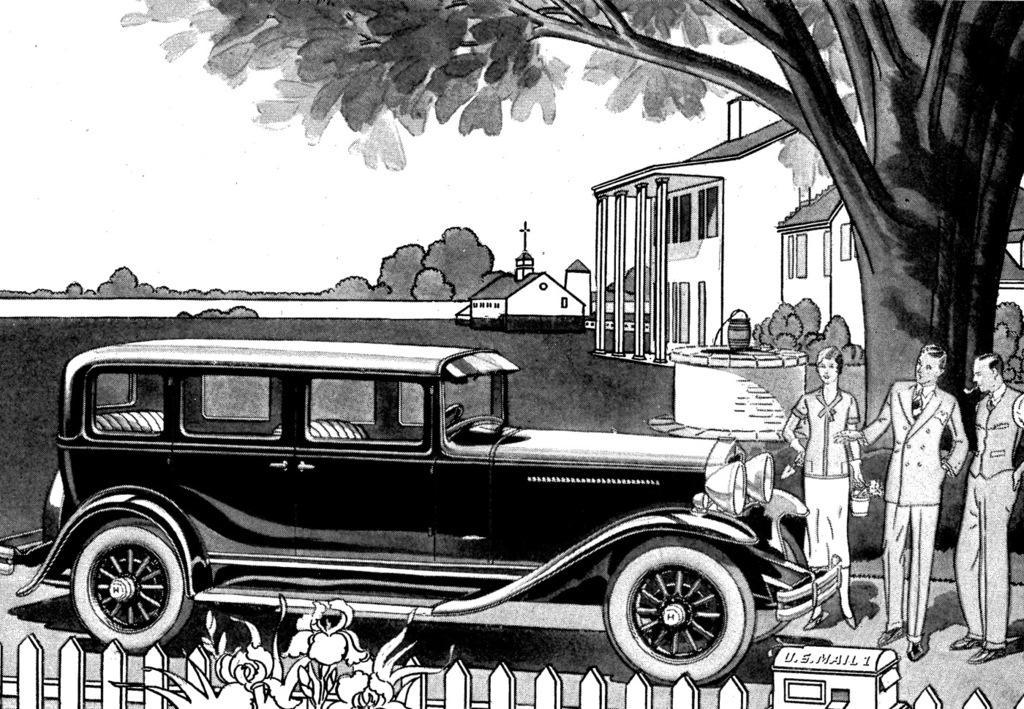Describe this image in one or two sentences. As we can see in the image there is a paper. On paper there is a drawing of fence, plants, trees, car and three people standing on the right side. 